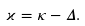<formula> <loc_0><loc_0><loc_500><loc_500>\varkappa = \kappa - \Delta .</formula> 